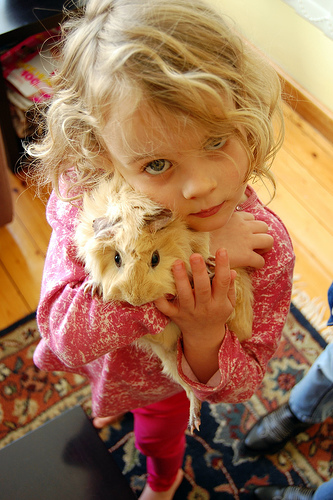<image>
Is the hamster in the girl? No. The hamster is not contained within the girl. These objects have a different spatial relationship. 